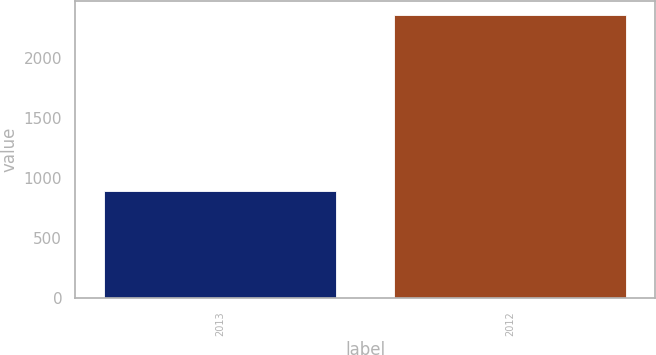Convert chart. <chart><loc_0><loc_0><loc_500><loc_500><bar_chart><fcel>2013<fcel>2012<nl><fcel>892<fcel>2354<nl></chart> 